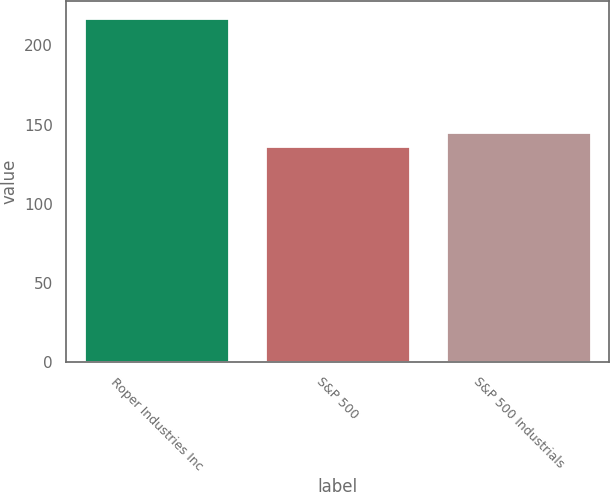Convert chart. <chart><loc_0><loc_0><loc_500><loc_500><bar_chart><fcel>Roper Industries Inc<fcel>S&P 500<fcel>S&P 500 Industrials<nl><fcel>217.01<fcel>136.3<fcel>145.32<nl></chart> 